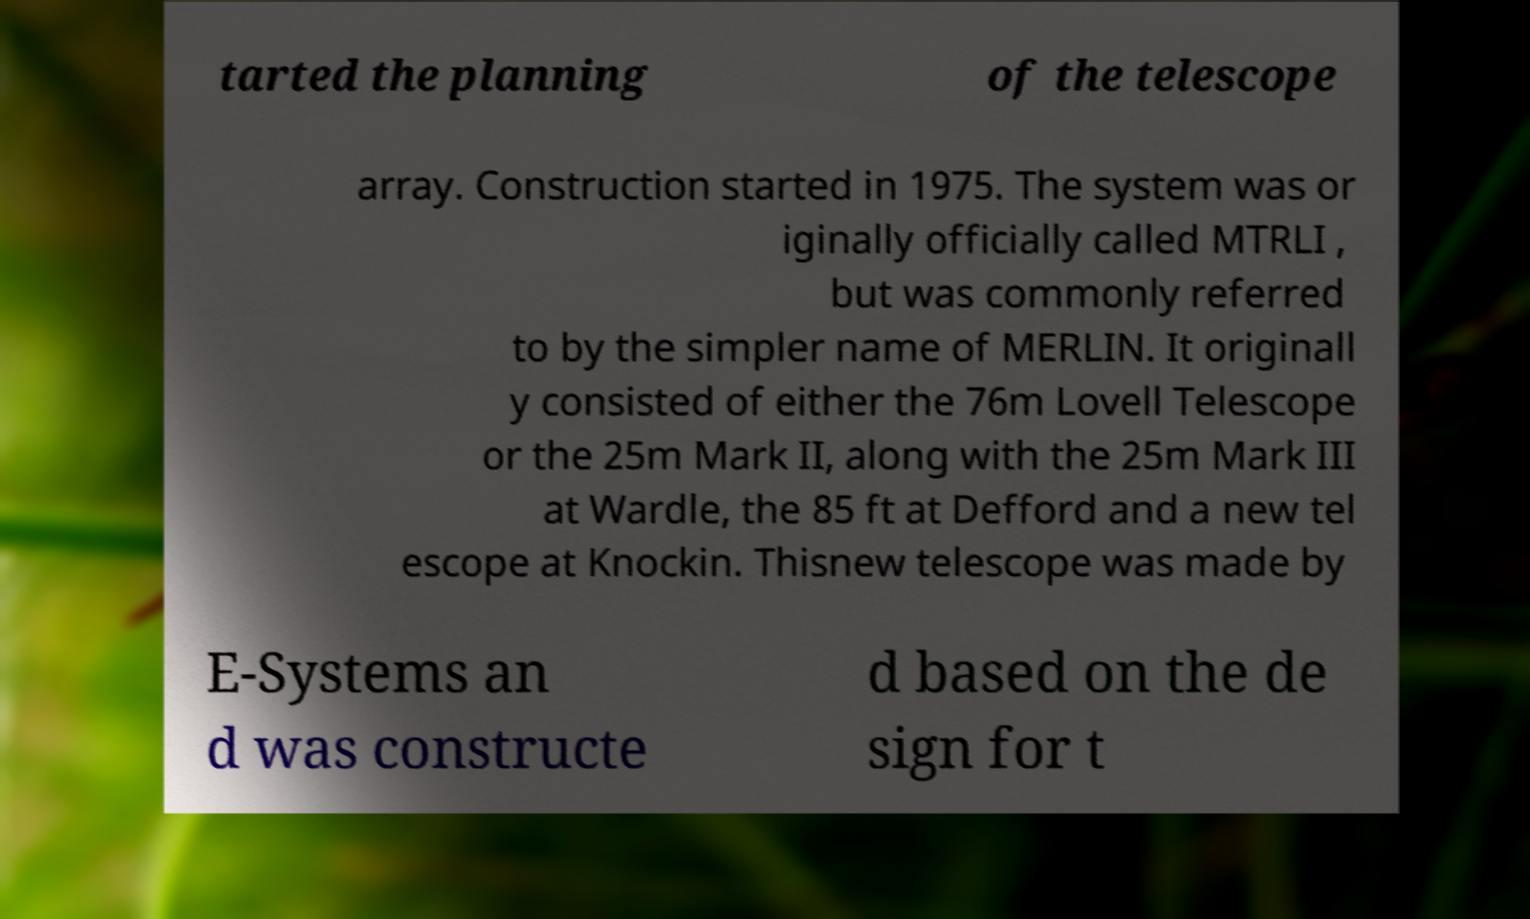Please identify and transcribe the text found in this image. tarted the planning of the telescope array. Construction started in 1975. The system was or iginally officially called MTRLI , but was commonly referred to by the simpler name of MERLIN. It originall y consisted of either the 76m Lovell Telescope or the 25m Mark II, along with the 25m Mark III at Wardle, the 85 ft at Defford and a new tel escope at Knockin. Thisnew telescope was made by E-Systems an d was constructe d based on the de sign for t 